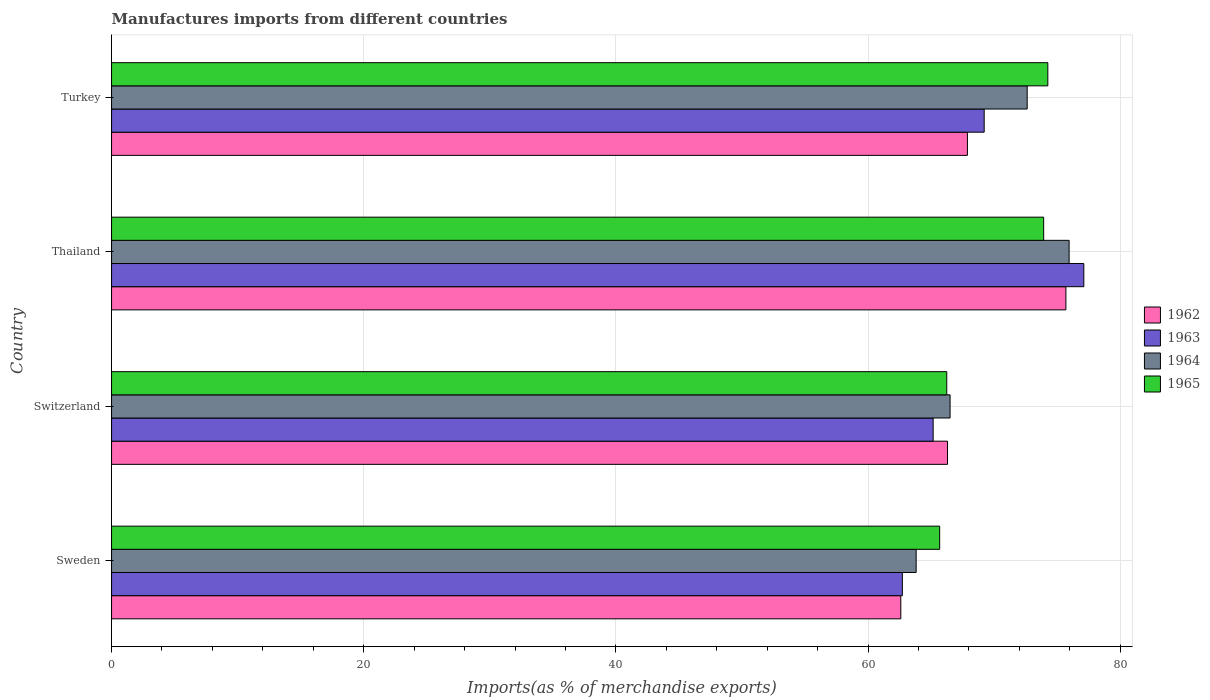How many groups of bars are there?
Provide a succinct answer. 4. Are the number of bars on each tick of the Y-axis equal?
Your answer should be compact. Yes. How many bars are there on the 2nd tick from the top?
Your answer should be compact. 4. How many bars are there on the 2nd tick from the bottom?
Give a very brief answer. 4. What is the percentage of imports to different countries in 1962 in Thailand?
Make the answer very short. 75.69. Across all countries, what is the maximum percentage of imports to different countries in 1963?
Make the answer very short. 77.12. Across all countries, what is the minimum percentage of imports to different countries in 1963?
Your answer should be very brief. 62.72. In which country was the percentage of imports to different countries in 1964 maximum?
Provide a short and direct response. Thailand. In which country was the percentage of imports to different countries in 1963 minimum?
Keep it short and to the point. Sweden. What is the total percentage of imports to different countries in 1964 in the graph?
Keep it short and to the point. 278.9. What is the difference between the percentage of imports to different countries in 1965 in Sweden and that in Thailand?
Provide a short and direct response. -8.25. What is the difference between the percentage of imports to different countries in 1962 in Switzerland and the percentage of imports to different countries in 1963 in Turkey?
Keep it short and to the point. -2.91. What is the average percentage of imports to different countries in 1964 per country?
Offer a terse response. 69.72. What is the difference between the percentage of imports to different countries in 1963 and percentage of imports to different countries in 1965 in Switzerland?
Ensure brevity in your answer.  -1.08. What is the ratio of the percentage of imports to different countries in 1965 in Thailand to that in Turkey?
Keep it short and to the point. 1. Is the percentage of imports to different countries in 1964 in Sweden less than that in Switzerland?
Ensure brevity in your answer.  Yes. Is the difference between the percentage of imports to different countries in 1963 in Thailand and Turkey greater than the difference between the percentage of imports to different countries in 1965 in Thailand and Turkey?
Make the answer very short. Yes. What is the difference between the highest and the second highest percentage of imports to different countries in 1964?
Provide a short and direct response. 3.33. What is the difference between the highest and the lowest percentage of imports to different countries in 1962?
Your response must be concise. 13.09. In how many countries, is the percentage of imports to different countries in 1963 greater than the average percentage of imports to different countries in 1963 taken over all countries?
Ensure brevity in your answer.  2. Is the sum of the percentage of imports to different countries in 1963 in Sweden and Switzerland greater than the maximum percentage of imports to different countries in 1965 across all countries?
Your answer should be very brief. Yes. What does the 1st bar from the top in Thailand represents?
Offer a very short reply. 1965. What does the 3rd bar from the bottom in Turkey represents?
Your answer should be very brief. 1964. How many bars are there?
Give a very brief answer. 16. How many countries are there in the graph?
Give a very brief answer. 4. Are the values on the major ticks of X-axis written in scientific E-notation?
Provide a succinct answer. No. Does the graph contain any zero values?
Your response must be concise. No. Does the graph contain grids?
Ensure brevity in your answer.  Yes. Where does the legend appear in the graph?
Provide a succinct answer. Center right. What is the title of the graph?
Your answer should be very brief. Manufactures imports from different countries. What is the label or title of the X-axis?
Your response must be concise. Imports(as % of merchandise exports). What is the label or title of the Y-axis?
Provide a short and direct response. Country. What is the Imports(as % of merchandise exports) of 1962 in Sweden?
Your response must be concise. 62.6. What is the Imports(as % of merchandise exports) in 1963 in Sweden?
Offer a terse response. 62.72. What is the Imports(as % of merchandise exports) of 1964 in Sweden?
Offer a very short reply. 63.82. What is the Imports(as % of merchandise exports) in 1965 in Sweden?
Keep it short and to the point. 65.68. What is the Imports(as % of merchandise exports) of 1962 in Switzerland?
Offer a terse response. 66.31. What is the Imports(as % of merchandise exports) in 1963 in Switzerland?
Offer a terse response. 65.16. What is the Imports(as % of merchandise exports) of 1964 in Switzerland?
Your response must be concise. 66.51. What is the Imports(as % of merchandise exports) of 1965 in Switzerland?
Offer a very short reply. 66.24. What is the Imports(as % of merchandise exports) of 1962 in Thailand?
Give a very brief answer. 75.69. What is the Imports(as % of merchandise exports) of 1963 in Thailand?
Make the answer very short. 77.12. What is the Imports(as % of merchandise exports) in 1964 in Thailand?
Keep it short and to the point. 75.95. What is the Imports(as % of merchandise exports) of 1965 in Thailand?
Your answer should be compact. 73.93. What is the Imports(as % of merchandise exports) of 1962 in Turkey?
Offer a terse response. 67.88. What is the Imports(as % of merchandise exports) of 1963 in Turkey?
Offer a terse response. 69.21. What is the Imports(as % of merchandise exports) in 1964 in Turkey?
Your response must be concise. 72.62. What is the Imports(as % of merchandise exports) in 1965 in Turkey?
Provide a succinct answer. 74.26. Across all countries, what is the maximum Imports(as % of merchandise exports) in 1962?
Make the answer very short. 75.69. Across all countries, what is the maximum Imports(as % of merchandise exports) in 1963?
Offer a very short reply. 77.12. Across all countries, what is the maximum Imports(as % of merchandise exports) of 1964?
Ensure brevity in your answer.  75.95. Across all countries, what is the maximum Imports(as % of merchandise exports) in 1965?
Offer a very short reply. 74.26. Across all countries, what is the minimum Imports(as % of merchandise exports) of 1962?
Ensure brevity in your answer.  62.6. Across all countries, what is the minimum Imports(as % of merchandise exports) of 1963?
Ensure brevity in your answer.  62.72. Across all countries, what is the minimum Imports(as % of merchandise exports) in 1964?
Keep it short and to the point. 63.82. Across all countries, what is the minimum Imports(as % of merchandise exports) in 1965?
Give a very brief answer. 65.68. What is the total Imports(as % of merchandise exports) of 1962 in the graph?
Your response must be concise. 272.48. What is the total Imports(as % of merchandise exports) of 1963 in the graph?
Offer a terse response. 274.22. What is the total Imports(as % of merchandise exports) in 1964 in the graph?
Offer a terse response. 278.9. What is the total Imports(as % of merchandise exports) in 1965 in the graph?
Provide a succinct answer. 280.12. What is the difference between the Imports(as % of merchandise exports) in 1962 in Sweden and that in Switzerland?
Provide a succinct answer. -3.71. What is the difference between the Imports(as % of merchandise exports) in 1963 in Sweden and that in Switzerland?
Give a very brief answer. -2.44. What is the difference between the Imports(as % of merchandise exports) in 1964 in Sweden and that in Switzerland?
Provide a succinct answer. -2.69. What is the difference between the Imports(as % of merchandise exports) in 1965 in Sweden and that in Switzerland?
Give a very brief answer. -0.56. What is the difference between the Imports(as % of merchandise exports) in 1962 in Sweden and that in Thailand?
Your answer should be very brief. -13.09. What is the difference between the Imports(as % of merchandise exports) of 1963 in Sweden and that in Thailand?
Offer a terse response. -14.39. What is the difference between the Imports(as % of merchandise exports) of 1964 in Sweden and that in Thailand?
Your answer should be compact. -12.13. What is the difference between the Imports(as % of merchandise exports) of 1965 in Sweden and that in Thailand?
Provide a short and direct response. -8.25. What is the difference between the Imports(as % of merchandise exports) of 1962 in Sweden and that in Turkey?
Keep it short and to the point. -5.28. What is the difference between the Imports(as % of merchandise exports) in 1963 in Sweden and that in Turkey?
Make the answer very short. -6.49. What is the difference between the Imports(as % of merchandise exports) of 1964 in Sweden and that in Turkey?
Make the answer very short. -8.81. What is the difference between the Imports(as % of merchandise exports) of 1965 in Sweden and that in Turkey?
Offer a very short reply. -8.58. What is the difference between the Imports(as % of merchandise exports) of 1962 in Switzerland and that in Thailand?
Your answer should be compact. -9.39. What is the difference between the Imports(as % of merchandise exports) in 1963 in Switzerland and that in Thailand?
Provide a short and direct response. -11.95. What is the difference between the Imports(as % of merchandise exports) in 1964 in Switzerland and that in Thailand?
Offer a terse response. -9.44. What is the difference between the Imports(as % of merchandise exports) in 1965 in Switzerland and that in Thailand?
Offer a very short reply. -7.69. What is the difference between the Imports(as % of merchandise exports) of 1962 in Switzerland and that in Turkey?
Make the answer very short. -1.58. What is the difference between the Imports(as % of merchandise exports) of 1963 in Switzerland and that in Turkey?
Offer a very short reply. -4.05. What is the difference between the Imports(as % of merchandise exports) in 1964 in Switzerland and that in Turkey?
Provide a short and direct response. -6.12. What is the difference between the Imports(as % of merchandise exports) of 1965 in Switzerland and that in Turkey?
Your response must be concise. -8.02. What is the difference between the Imports(as % of merchandise exports) of 1962 in Thailand and that in Turkey?
Offer a very short reply. 7.81. What is the difference between the Imports(as % of merchandise exports) of 1963 in Thailand and that in Turkey?
Offer a terse response. 7.9. What is the difference between the Imports(as % of merchandise exports) in 1964 in Thailand and that in Turkey?
Make the answer very short. 3.33. What is the difference between the Imports(as % of merchandise exports) in 1965 in Thailand and that in Turkey?
Offer a very short reply. -0.33. What is the difference between the Imports(as % of merchandise exports) of 1962 in Sweden and the Imports(as % of merchandise exports) of 1963 in Switzerland?
Keep it short and to the point. -2.57. What is the difference between the Imports(as % of merchandise exports) in 1962 in Sweden and the Imports(as % of merchandise exports) in 1964 in Switzerland?
Offer a terse response. -3.91. What is the difference between the Imports(as % of merchandise exports) of 1962 in Sweden and the Imports(as % of merchandise exports) of 1965 in Switzerland?
Provide a succinct answer. -3.65. What is the difference between the Imports(as % of merchandise exports) of 1963 in Sweden and the Imports(as % of merchandise exports) of 1964 in Switzerland?
Keep it short and to the point. -3.78. What is the difference between the Imports(as % of merchandise exports) of 1963 in Sweden and the Imports(as % of merchandise exports) of 1965 in Switzerland?
Make the answer very short. -3.52. What is the difference between the Imports(as % of merchandise exports) of 1964 in Sweden and the Imports(as % of merchandise exports) of 1965 in Switzerland?
Give a very brief answer. -2.43. What is the difference between the Imports(as % of merchandise exports) in 1962 in Sweden and the Imports(as % of merchandise exports) in 1963 in Thailand?
Offer a terse response. -14.52. What is the difference between the Imports(as % of merchandise exports) of 1962 in Sweden and the Imports(as % of merchandise exports) of 1964 in Thailand?
Provide a short and direct response. -13.35. What is the difference between the Imports(as % of merchandise exports) in 1962 in Sweden and the Imports(as % of merchandise exports) in 1965 in Thailand?
Give a very brief answer. -11.33. What is the difference between the Imports(as % of merchandise exports) in 1963 in Sweden and the Imports(as % of merchandise exports) in 1964 in Thailand?
Give a very brief answer. -13.23. What is the difference between the Imports(as % of merchandise exports) of 1963 in Sweden and the Imports(as % of merchandise exports) of 1965 in Thailand?
Provide a succinct answer. -11.21. What is the difference between the Imports(as % of merchandise exports) of 1964 in Sweden and the Imports(as % of merchandise exports) of 1965 in Thailand?
Provide a succinct answer. -10.11. What is the difference between the Imports(as % of merchandise exports) of 1962 in Sweden and the Imports(as % of merchandise exports) of 1963 in Turkey?
Your answer should be compact. -6.61. What is the difference between the Imports(as % of merchandise exports) in 1962 in Sweden and the Imports(as % of merchandise exports) in 1964 in Turkey?
Your answer should be compact. -10.02. What is the difference between the Imports(as % of merchandise exports) in 1962 in Sweden and the Imports(as % of merchandise exports) in 1965 in Turkey?
Your answer should be very brief. -11.66. What is the difference between the Imports(as % of merchandise exports) in 1963 in Sweden and the Imports(as % of merchandise exports) in 1964 in Turkey?
Ensure brevity in your answer.  -9.9. What is the difference between the Imports(as % of merchandise exports) of 1963 in Sweden and the Imports(as % of merchandise exports) of 1965 in Turkey?
Provide a succinct answer. -11.54. What is the difference between the Imports(as % of merchandise exports) of 1964 in Sweden and the Imports(as % of merchandise exports) of 1965 in Turkey?
Provide a succinct answer. -10.44. What is the difference between the Imports(as % of merchandise exports) of 1962 in Switzerland and the Imports(as % of merchandise exports) of 1963 in Thailand?
Your answer should be very brief. -10.81. What is the difference between the Imports(as % of merchandise exports) of 1962 in Switzerland and the Imports(as % of merchandise exports) of 1964 in Thailand?
Make the answer very short. -9.64. What is the difference between the Imports(as % of merchandise exports) of 1962 in Switzerland and the Imports(as % of merchandise exports) of 1965 in Thailand?
Provide a short and direct response. -7.63. What is the difference between the Imports(as % of merchandise exports) of 1963 in Switzerland and the Imports(as % of merchandise exports) of 1964 in Thailand?
Your answer should be compact. -10.78. What is the difference between the Imports(as % of merchandise exports) in 1963 in Switzerland and the Imports(as % of merchandise exports) in 1965 in Thailand?
Ensure brevity in your answer.  -8.77. What is the difference between the Imports(as % of merchandise exports) in 1964 in Switzerland and the Imports(as % of merchandise exports) in 1965 in Thailand?
Your response must be concise. -7.42. What is the difference between the Imports(as % of merchandise exports) in 1962 in Switzerland and the Imports(as % of merchandise exports) in 1963 in Turkey?
Offer a terse response. -2.91. What is the difference between the Imports(as % of merchandise exports) in 1962 in Switzerland and the Imports(as % of merchandise exports) in 1964 in Turkey?
Give a very brief answer. -6.32. What is the difference between the Imports(as % of merchandise exports) in 1962 in Switzerland and the Imports(as % of merchandise exports) in 1965 in Turkey?
Provide a short and direct response. -7.96. What is the difference between the Imports(as % of merchandise exports) of 1963 in Switzerland and the Imports(as % of merchandise exports) of 1964 in Turkey?
Make the answer very short. -7.46. What is the difference between the Imports(as % of merchandise exports) of 1963 in Switzerland and the Imports(as % of merchandise exports) of 1965 in Turkey?
Your answer should be compact. -9.1. What is the difference between the Imports(as % of merchandise exports) in 1964 in Switzerland and the Imports(as % of merchandise exports) in 1965 in Turkey?
Offer a very short reply. -7.75. What is the difference between the Imports(as % of merchandise exports) in 1962 in Thailand and the Imports(as % of merchandise exports) in 1963 in Turkey?
Keep it short and to the point. 6.48. What is the difference between the Imports(as % of merchandise exports) of 1962 in Thailand and the Imports(as % of merchandise exports) of 1964 in Turkey?
Offer a terse response. 3.07. What is the difference between the Imports(as % of merchandise exports) of 1962 in Thailand and the Imports(as % of merchandise exports) of 1965 in Turkey?
Make the answer very short. 1.43. What is the difference between the Imports(as % of merchandise exports) of 1963 in Thailand and the Imports(as % of merchandise exports) of 1964 in Turkey?
Offer a very short reply. 4.49. What is the difference between the Imports(as % of merchandise exports) of 1963 in Thailand and the Imports(as % of merchandise exports) of 1965 in Turkey?
Provide a succinct answer. 2.85. What is the difference between the Imports(as % of merchandise exports) of 1964 in Thailand and the Imports(as % of merchandise exports) of 1965 in Turkey?
Make the answer very short. 1.69. What is the average Imports(as % of merchandise exports) in 1962 per country?
Offer a terse response. 68.12. What is the average Imports(as % of merchandise exports) in 1963 per country?
Your response must be concise. 68.55. What is the average Imports(as % of merchandise exports) of 1964 per country?
Your answer should be compact. 69.72. What is the average Imports(as % of merchandise exports) of 1965 per country?
Your answer should be very brief. 70.03. What is the difference between the Imports(as % of merchandise exports) in 1962 and Imports(as % of merchandise exports) in 1963 in Sweden?
Ensure brevity in your answer.  -0.12. What is the difference between the Imports(as % of merchandise exports) in 1962 and Imports(as % of merchandise exports) in 1964 in Sweden?
Your response must be concise. -1.22. What is the difference between the Imports(as % of merchandise exports) of 1962 and Imports(as % of merchandise exports) of 1965 in Sweden?
Keep it short and to the point. -3.08. What is the difference between the Imports(as % of merchandise exports) in 1963 and Imports(as % of merchandise exports) in 1964 in Sweden?
Provide a short and direct response. -1.09. What is the difference between the Imports(as % of merchandise exports) in 1963 and Imports(as % of merchandise exports) in 1965 in Sweden?
Your answer should be compact. -2.96. What is the difference between the Imports(as % of merchandise exports) in 1964 and Imports(as % of merchandise exports) in 1965 in Sweden?
Make the answer very short. -1.87. What is the difference between the Imports(as % of merchandise exports) of 1962 and Imports(as % of merchandise exports) of 1963 in Switzerland?
Keep it short and to the point. 1.14. What is the difference between the Imports(as % of merchandise exports) of 1962 and Imports(as % of merchandise exports) of 1964 in Switzerland?
Ensure brevity in your answer.  -0.2. What is the difference between the Imports(as % of merchandise exports) of 1962 and Imports(as % of merchandise exports) of 1965 in Switzerland?
Offer a terse response. 0.06. What is the difference between the Imports(as % of merchandise exports) of 1963 and Imports(as % of merchandise exports) of 1964 in Switzerland?
Give a very brief answer. -1.34. What is the difference between the Imports(as % of merchandise exports) of 1963 and Imports(as % of merchandise exports) of 1965 in Switzerland?
Offer a terse response. -1.08. What is the difference between the Imports(as % of merchandise exports) of 1964 and Imports(as % of merchandise exports) of 1965 in Switzerland?
Offer a terse response. 0.26. What is the difference between the Imports(as % of merchandise exports) in 1962 and Imports(as % of merchandise exports) in 1963 in Thailand?
Keep it short and to the point. -1.42. What is the difference between the Imports(as % of merchandise exports) of 1962 and Imports(as % of merchandise exports) of 1964 in Thailand?
Give a very brief answer. -0.26. What is the difference between the Imports(as % of merchandise exports) of 1962 and Imports(as % of merchandise exports) of 1965 in Thailand?
Provide a short and direct response. 1.76. What is the difference between the Imports(as % of merchandise exports) in 1963 and Imports(as % of merchandise exports) in 1964 in Thailand?
Your answer should be very brief. 1.17. What is the difference between the Imports(as % of merchandise exports) in 1963 and Imports(as % of merchandise exports) in 1965 in Thailand?
Keep it short and to the point. 3.18. What is the difference between the Imports(as % of merchandise exports) of 1964 and Imports(as % of merchandise exports) of 1965 in Thailand?
Provide a succinct answer. 2.02. What is the difference between the Imports(as % of merchandise exports) of 1962 and Imports(as % of merchandise exports) of 1963 in Turkey?
Offer a very short reply. -1.33. What is the difference between the Imports(as % of merchandise exports) in 1962 and Imports(as % of merchandise exports) in 1964 in Turkey?
Your answer should be compact. -4.74. What is the difference between the Imports(as % of merchandise exports) of 1962 and Imports(as % of merchandise exports) of 1965 in Turkey?
Ensure brevity in your answer.  -6.38. What is the difference between the Imports(as % of merchandise exports) of 1963 and Imports(as % of merchandise exports) of 1964 in Turkey?
Offer a terse response. -3.41. What is the difference between the Imports(as % of merchandise exports) in 1963 and Imports(as % of merchandise exports) in 1965 in Turkey?
Your response must be concise. -5.05. What is the difference between the Imports(as % of merchandise exports) of 1964 and Imports(as % of merchandise exports) of 1965 in Turkey?
Provide a succinct answer. -1.64. What is the ratio of the Imports(as % of merchandise exports) in 1962 in Sweden to that in Switzerland?
Give a very brief answer. 0.94. What is the ratio of the Imports(as % of merchandise exports) of 1963 in Sweden to that in Switzerland?
Give a very brief answer. 0.96. What is the ratio of the Imports(as % of merchandise exports) in 1964 in Sweden to that in Switzerland?
Ensure brevity in your answer.  0.96. What is the ratio of the Imports(as % of merchandise exports) of 1965 in Sweden to that in Switzerland?
Make the answer very short. 0.99. What is the ratio of the Imports(as % of merchandise exports) of 1962 in Sweden to that in Thailand?
Offer a very short reply. 0.83. What is the ratio of the Imports(as % of merchandise exports) in 1963 in Sweden to that in Thailand?
Your answer should be compact. 0.81. What is the ratio of the Imports(as % of merchandise exports) of 1964 in Sweden to that in Thailand?
Provide a succinct answer. 0.84. What is the ratio of the Imports(as % of merchandise exports) of 1965 in Sweden to that in Thailand?
Ensure brevity in your answer.  0.89. What is the ratio of the Imports(as % of merchandise exports) in 1962 in Sweden to that in Turkey?
Offer a terse response. 0.92. What is the ratio of the Imports(as % of merchandise exports) of 1963 in Sweden to that in Turkey?
Keep it short and to the point. 0.91. What is the ratio of the Imports(as % of merchandise exports) of 1964 in Sweden to that in Turkey?
Offer a terse response. 0.88. What is the ratio of the Imports(as % of merchandise exports) of 1965 in Sweden to that in Turkey?
Keep it short and to the point. 0.88. What is the ratio of the Imports(as % of merchandise exports) of 1962 in Switzerland to that in Thailand?
Offer a very short reply. 0.88. What is the ratio of the Imports(as % of merchandise exports) in 1963 in Switzerland to that in Thailand?
Your response must be concise. 0.84. What is the ratio of the Imports(as % of merchandise exports) in 1964 in Switzerland to that in Thailand?
Your answer should be compact. 0.88. What is the ratio of the Imports(as % of merchandise exports) in 1965 in Switzerland to that in Thailand?
Keep it short and to the point. 0.9. What is the ratio of the Imports(as % of merchandise exports) in 1962 in Switzerland to that in Turkey?
Offer a terse response. 0.98. What is the ratio of the Imports(as % of merchandise exports) in 1963 in Switzerland to that in Turkey?
Provide a short and direct response. 0.94. What is the ratio of the Imports(as % of merchandise exports) in 1964 in Switzerland to that in Turkey?
Provide a succinct answer. 0.92. What is the ratio of the Imports(as % of merchandise exports) in 1965 in Switzerland to that in Turkey?
Your answer should be compact. 0.89. What is the ratio of the Imports(as % of merchandise exports) in 1962 in Thailand to that in Turkey?
Give a very brief answer. 1.11. What is the ratio of the Imports(as % of merchandise exports) in 1963 in Thailand to that in Turkey?
Your response must be concise. 1.11. What is the ratio of the Imports(as % of merchandise exports) of 1964 in Thailand to that in Turkey?
Keep it short and to the point. 1.05. What is the ratio of the Imports(as % of merchandise exports) in 1965 in Thailand to that in Turkey?
Your response must be concise. 1. What is the difference between the highest and the second highest Imports(as % of merchandise exports) in 1962?
Offer a terse response. 7.81. What is the difference between the highest and the second highest Imports(as % of merchandise exports) of 1963?
Provide a short and direct response. 7.9. What is the difference between the highest and the second highest Imports(as % of merchandise exports) in 1964?
Your answer should be compact. 3.33. What is the difference between the highest and the second highest Imports(as % of merchandise exports) in 1965?
Offer a terse response. 0.33. What is the difference between the highest and the lowest Imports(as % of merchandise exports) of 1962?
Keep it short and to the point. 13.09. What is the difference between the highest and the lowest Imports(as % of merchandise exports) of 1963?
Offer a very short reply. 14.39. What is the difference between the highest and the lowest Imports(as % of merchandise exports) of 1964?
Keep it short and to the point. 12.13. What is the difference between the highest and the lowest Imports(as % of merchandise exports) in 1965?
Your answer should be compact. 8.58. 